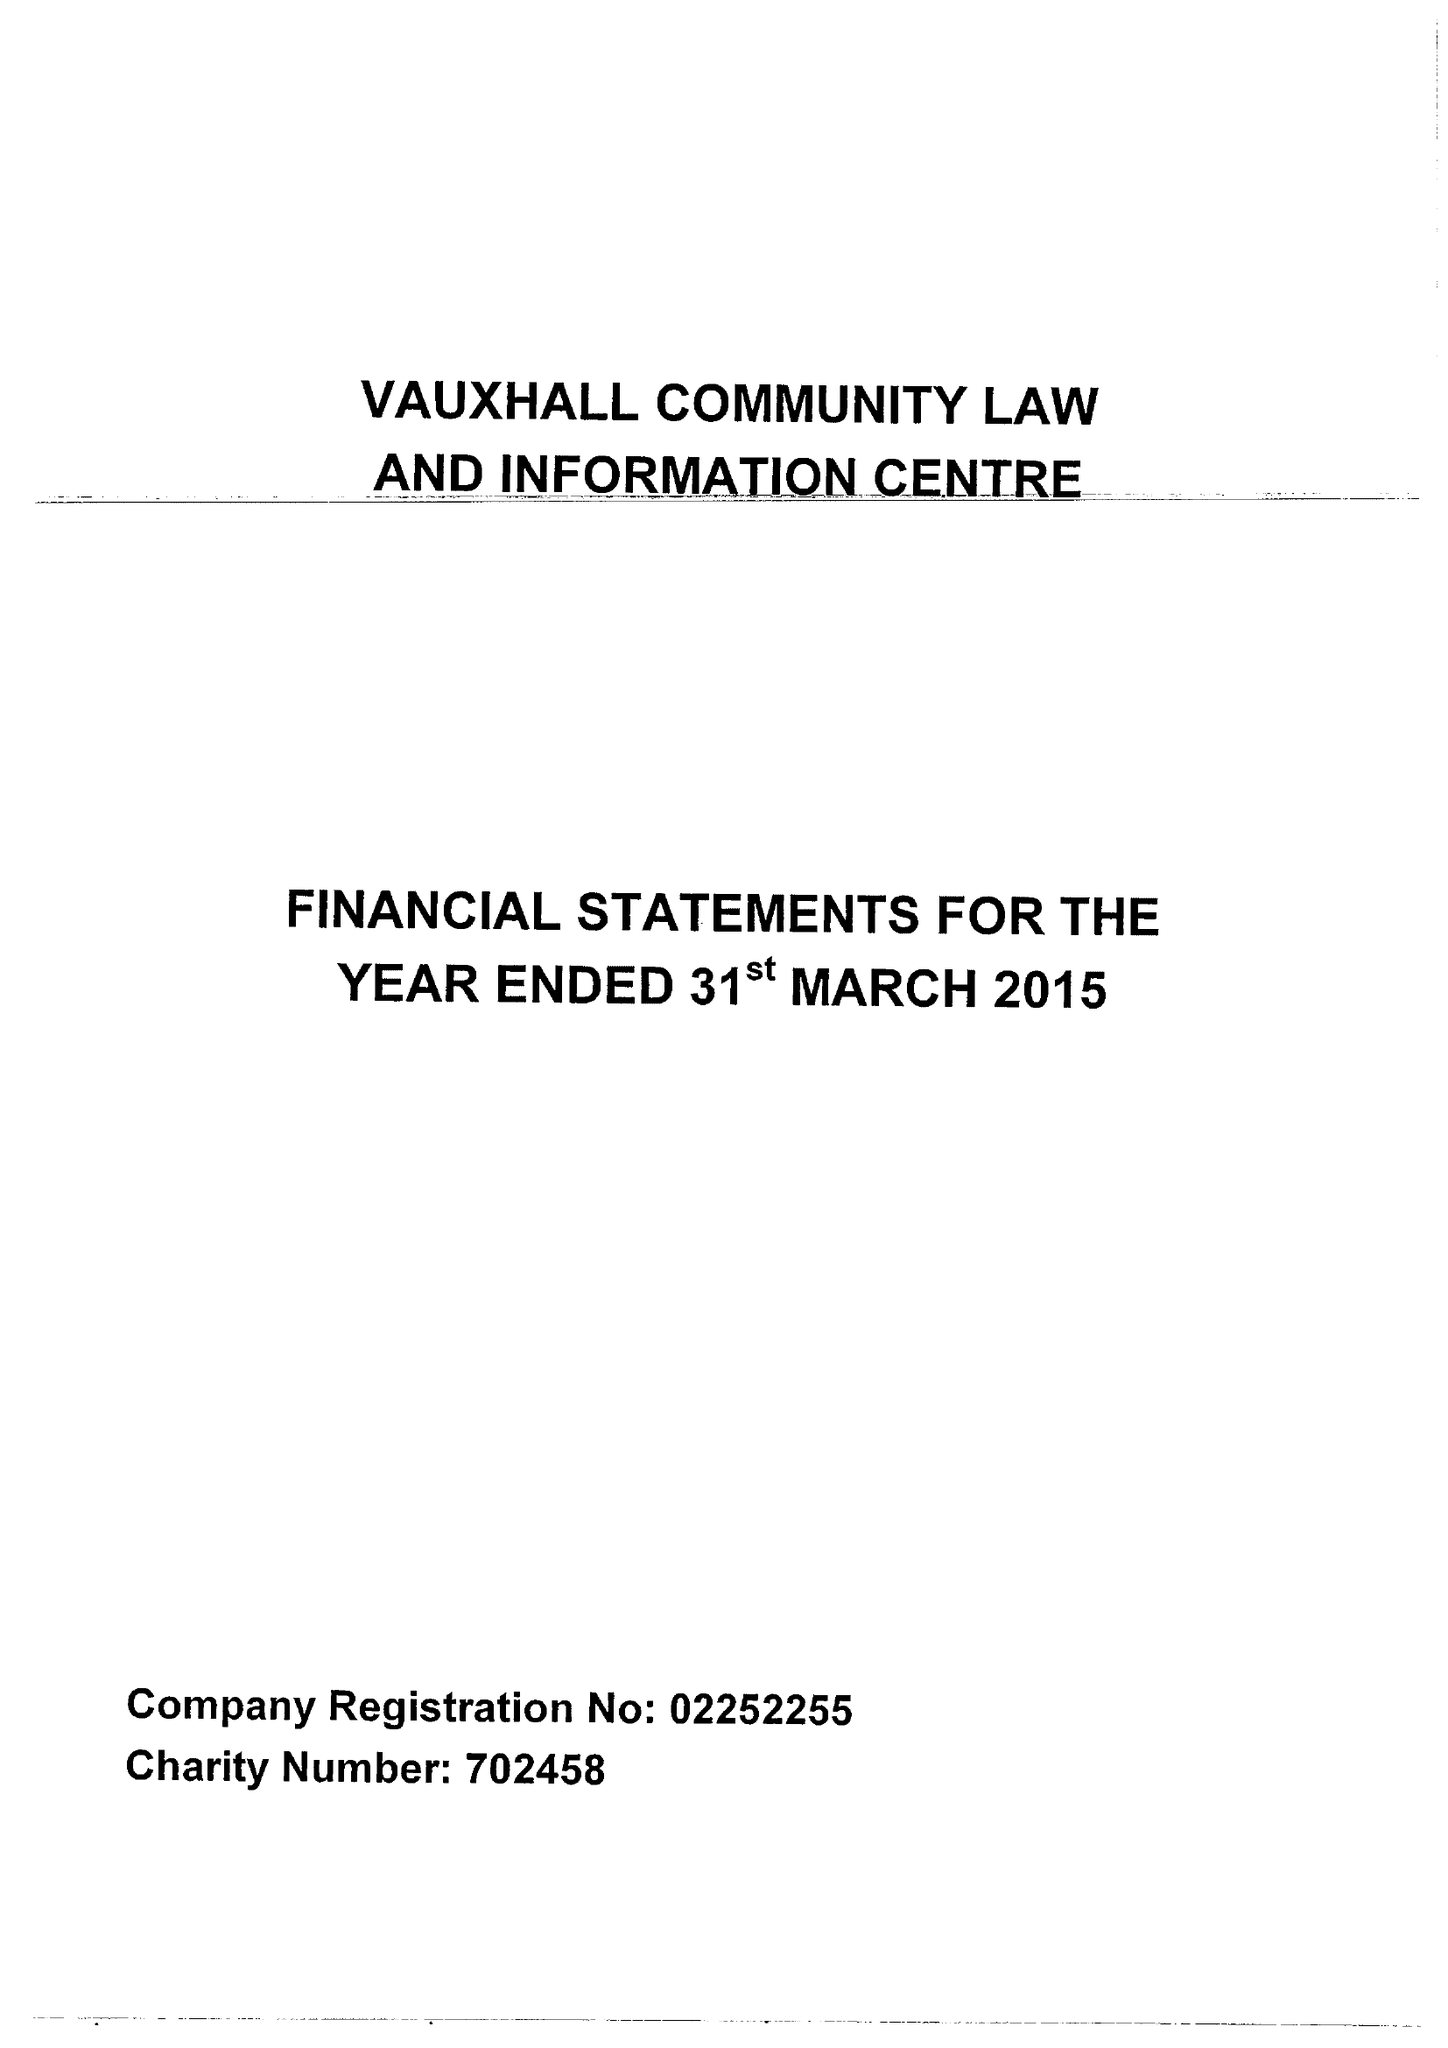What is the value for the address__post_town?
Answer the question using a single word or phrase. LIVERPOOL 